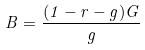Convert formula to latex. <formula><loc_0><loc_0><loc_500><loc_500>B = \frac { ( 1 - r - g ) G } { g }</formula> 